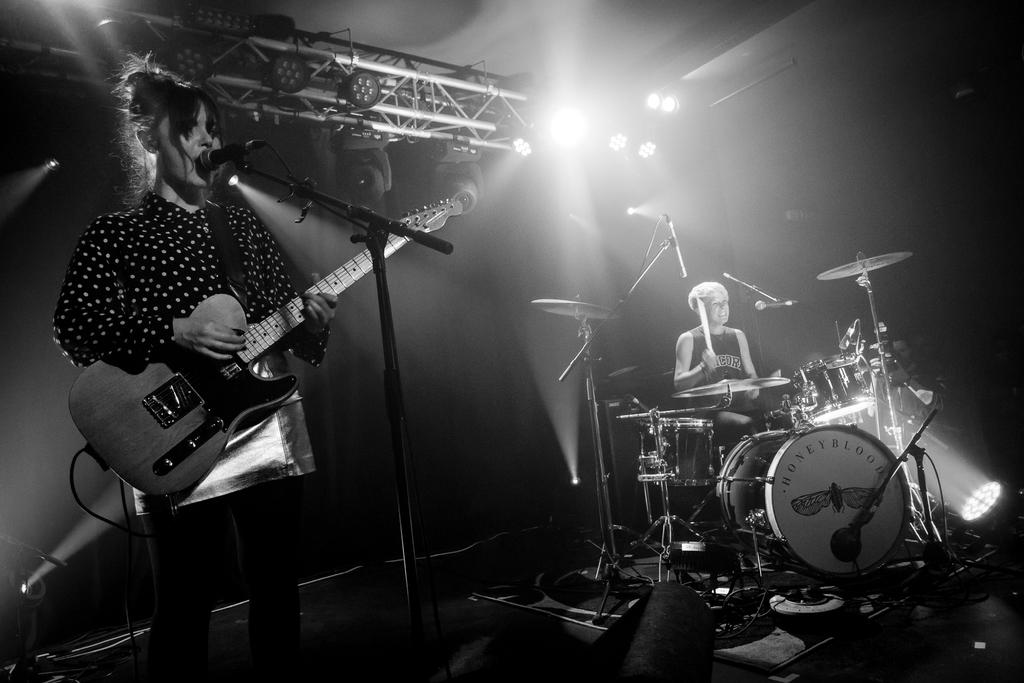How many people are in the image? There are two people in the image. What is the standing person doing in the image? The standing person is holding a guitar and standing in front of a mic. What is the sitting person doing in the image? The sitting person is next to a drum set. Can you see any sea creatures in the image? There are no sea creatures present in the image. 